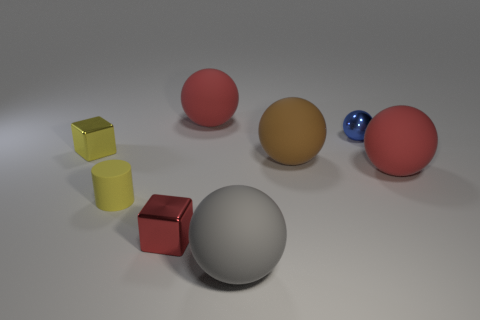Subtract 1 spheres. How many spheres are left? 4 Subtract all purple spheres. Subtract all red cubes. How many spheres are left? 5 Add 1 gray matte cylinders. How many objects exist? 9 Subtract all cylinders. How many objects are left? 7 Subtract 0 green cylinders. How many objects are left? 8 Subtract all large purple metallic things. Subtract all brown matte things. How many objects are left? 7 Add 1 yellow shiny things. How many yellow shiny things are left? 2 Add 7 small purple matte blocks. How many small purple matte blocks exist? 7 